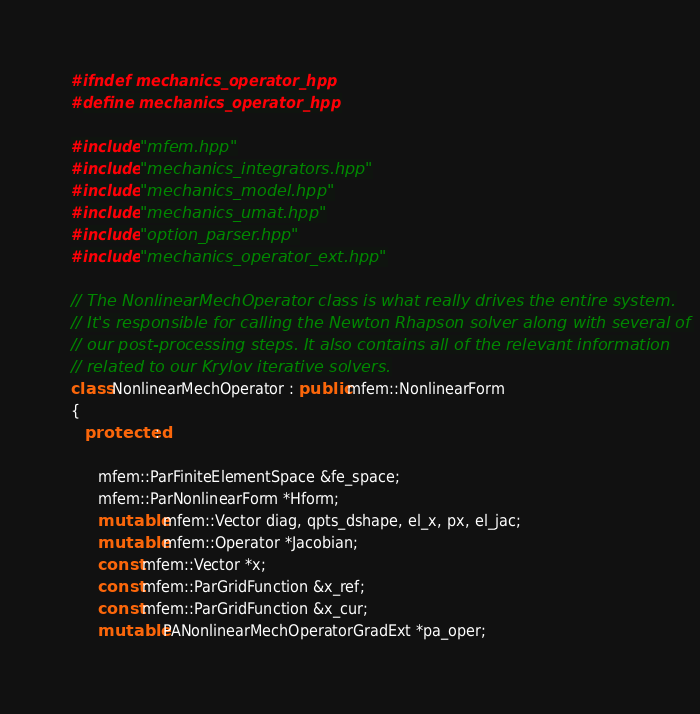<code> <loc_0><loc_0><loc_500><loc_500><_C++_>
#ifndef mechanics_operator_hpp
#define mechanics_operator_hpp

#include "mfem.hpp"
#include "mechanics_integrators.hpp"
#include "mechanics_model.hpp"
#include "mechanics_umat.hpp"
#include "option_parser.hpp"
#include "mechanics_operator_ext.hpp"

// The NonlinearMechOperator class is what really drives the entire system.
// It's responsible for calling the Newton Rhapson solver along with several of
// our post-processing steps. It also contains all of the relevant information
// related to our Krylov iterative solvers.
class NonlinearMechOperator : public mfem::NonlinearForm
{
   protected:

      mfem::ParFiniteElementSpace &fe_space;
      mfem::ParNonlinearForm *Hform;
      mutable mfem::Vector diag, qpts_dshape, el_x, px, el_jac;
      mutable mfem::Operator *Jacobian;
      const mfem::Vector *x;
      const mfem::ParGridFunction &x_ref;
      const mfem::ParGridFunction &x_cur;
      mutable PANonlinearMechOperatorGradExt *pa_oper;</code> 